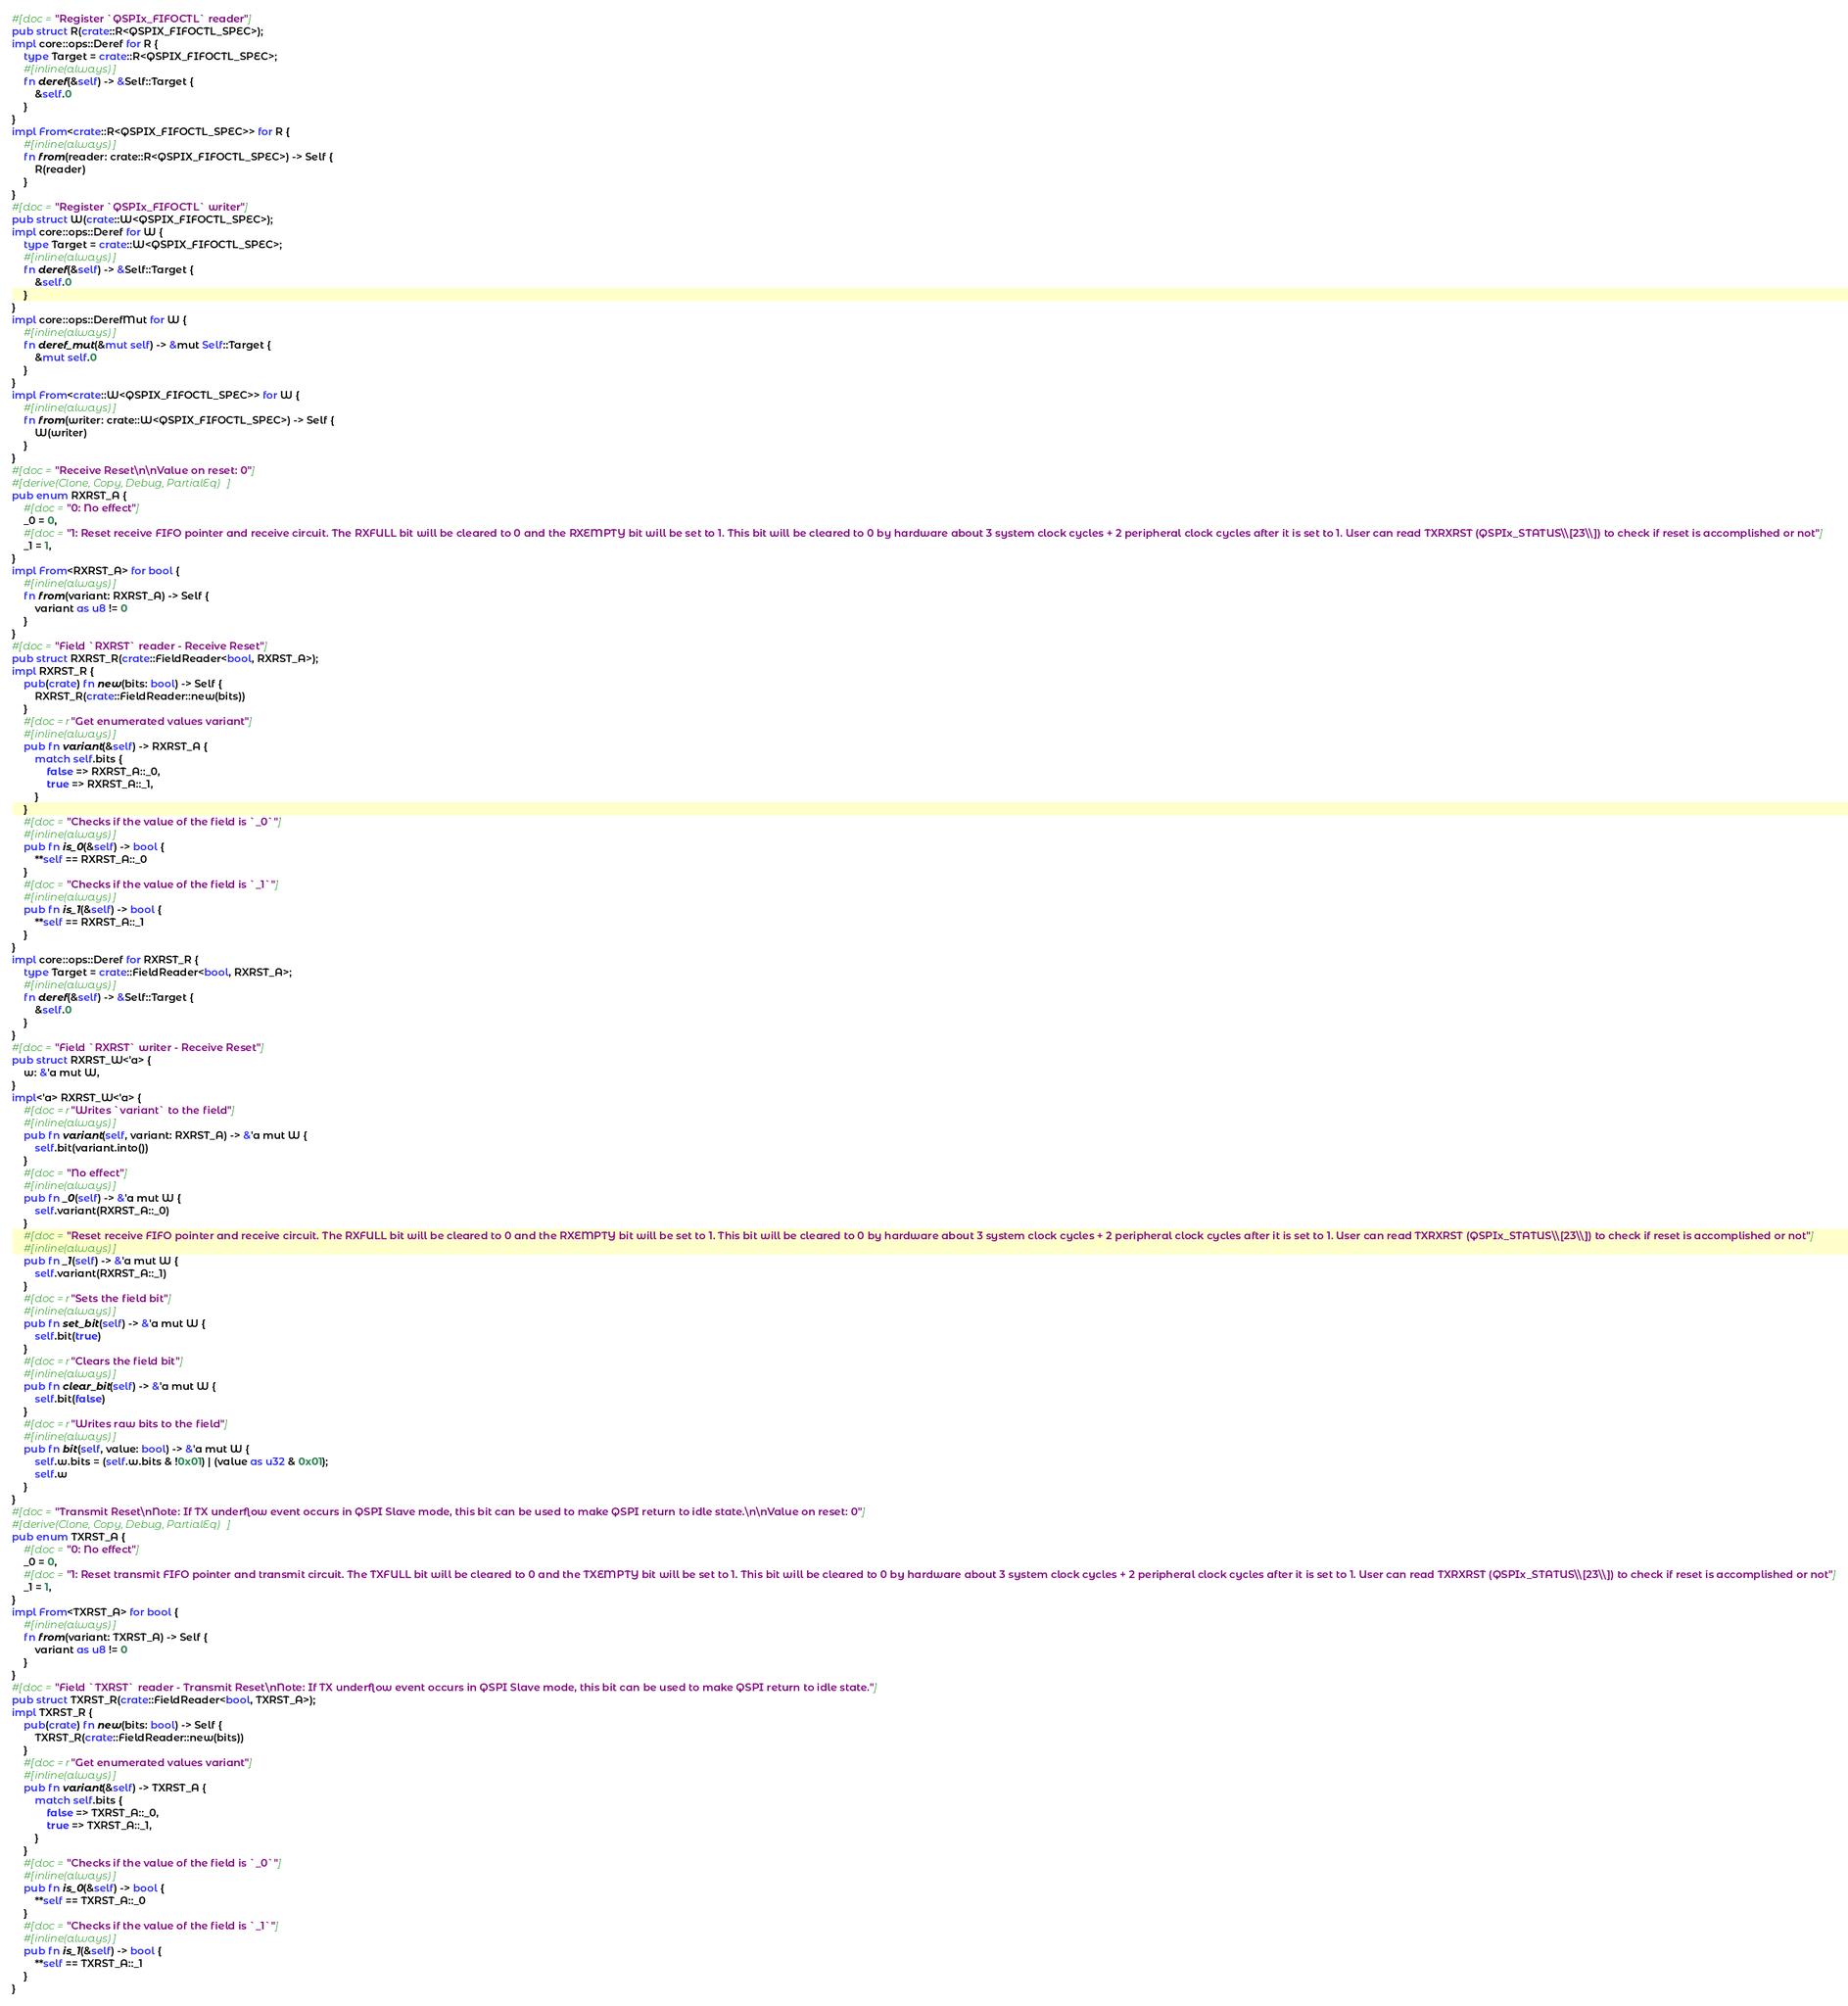<code> <loc_0><loc_0><loc_500><loc_500><_Rust_>#[doc = "Register `QSPIx_FIFOCTL` reader"]
pub struct R(crate::R<QSPIX_FIFOCTL_SPEC>);
impl core::ops::Deref for R {
    type Target = crate::R<QSPIX_FIFOCTL_SPEC>;
    #[inline(always)]
    fn deref(&self) -> &Self::Target {
        &self.0
    }
}
impl From<crate::R<QSPIX_FIFOCTL_SPEC>> for R {
    #[inline(always)]
    fn from(reader: crate::R<QSPIX_FIFOCTL_SPEC>) -> Self {
        R(reader)
    }
}
#[doc = "Register `QSPIx_FIFOCTL` writer"]
pub struct W(crate::W<QSPIX_FIFOCTL_SPEC>);
impl core::ops::Deref for W {
    type Target = crate::W<QSPIX_FIFOCTL_SPEC>;
    #[inline(always)]
    fn deref(&self) -> &Self::Target {
        &self.0
    }
}
impl core::ops::DerefMut for W {
    #[inline(always)]
    fn deref_mut(&mut self) -> &mut Self::Target {
        &mut self.0
    }
}
impl From<crate::W<QSPIX_FIFOCTL_SPEC>> for W {
    #[inline(always)]
    fn from(writer: crate::W<QSPIX_FIFOCTL_SPEC>) -> Self {
        W(writer)
    }
}
#[doc = "Receive Reset\n\nValue on reset: 0"]
#[derive(Clone, Copy, Debug, PartialEq)]
pub enum RXRST_A {
    #[doc = "0: No effect"]
    _0 = 0,
    #[doc = "1: Reset receive FIFO pointer and receive circuit. The RXFULL bit will be cleared to 0 and the RXEMPTY bit will be set to 1. This bit will be cleared to 0 by hardware about 3 system clock cycles + 2 peripheral clock cycles after it is set to 1. User can read TXRXRST (QSPIx_STATUS\\[23\\]) to check if reset is accomplished or not"]
    _1 = 1,
}
impl From<RXRST_A> for bool {
    #[inline(always)]
    fn from(variant: RXRST_A) -> Self {
        variant as u8 != 0
    }
}
#[doc = "Field `RXRST` reader - Receive Reset"]
pub struct RXRST_R(crate::FieldReader<bool, RXRST_A>);
impl RXRST_R {
    pub(crate) fn new(bits: bool) -> Self {
        RXRST_R(crate::FieldReader::new(bits))
    }
    #[doc = r"Get enumerated values variant"]
    #[inline(always)]
    pub fn variant(&self) -> RXRST_A {
        match self.bits {
            false => RXRST_A::_0,
            true => RXRST_A::_1,
        }
    }
    #[doc = "Checks if the value of the field is `_0`"]
    #[inline(always)]
    pub fn is_0(&self) -> bool {
        **self == RXRST_A::_0
    }
    #[doc = "Checks if the value of the field is `_1`"]
    #[inline(always)]
    pub fn is_1(&self) -> bool {
        **self == RXRST_A::_1
    }
}
impl core::ops::Deref for RXRST_R {
    type Target = crate::FieldReader<bool, RXRST_A>;
    #[inline(always)]
    fn deref(&self) -> &Self::Target {
        &self.0
    }
}
#[doc = "Field `RXRST` writer - Receive Reset"]
pub struct RXRST_W<'a> {
    w: &'a mut W,
}
impl<'a> RXRST_W<'a> {
    #[doc = r"Writes `variant` to the field"]
    #[inline(always)]
    pub fn variant(self, variant: RXRST_A) -> &'a mut W {
        self.bit(variant.into())
    }
    #[doc = "No effect"]
    #[inline(always)]
    pub fn _0(self) -> &'a mut W {
        self.variant(RXRST_A::_0)
    }
    #[doc = "Reset receive FIFO pointer and receive circuit. The RXFULL bit will be cleared to 0 and the RXEMPTY bit will be set to 1. This bit will be cleared to 0 by hardware about 3 system clock cycles + 2 peripheral clock cycles after it is set to 1. User can read TXRXRST (QSPIx_STATUS\\[23\\]) to check if reset is accomplished or not"]
    #[inline(always)]
    pub fn _1(self) -> &'a mut W {
        self.variant(RXRST_A::_1)
    }
    #[doc = r"Sets the field bit"]
    #[inline(always)]
    pub fn set_bit(self) -> &'a mut W {
        self.bit(true)
    }
    #[doc = r"Clears the field bit"]
    #[inline(always)]
    pub fn clear_bit(self) -> &'a mut W {
        self.bit(false)
    }
    #[doc = r"Writes raw bits to the field"]
    #[inline(always)]
    pub fn bit(self, value: bool) -> &'a mut W {
        self.w.bits = (self.w.bits & !0x01) | (value as u32 & 0x01);
        self.w
    }
}
#[doc = "Transmit Reset\nNote: If TX underflow event occurs in QSPI Slave mode, this bit can be used to make QSPI return to idle state.\n\nValue on reset: 0"]
#[derive(Clone, Copy, Debug, PartialEq)]
pub enum TXRST_A {
    #[doc = "0: No effect"]
    _0 = 0,
    #[doc = "1: Reset transmit FIFO pointer and transmit circuit. The TXFULL bit will be cleared to 0 and the TXEMPTY bit will be set to 1. This bit will be cleared to 0 by hardware about 3 system clock cycles + 2 peripheral clock cycles after it is set to 1. User can read TXRXRST (QSPIx_STATUS\\[23\\]) to check if reset is accomplished or not"]
    _1 = 1,
}
impl From<TXRST_A> for bool {
    #[inline(always)]
    fn from(variant: TXRST_A) -> Self {
        variant as u8 != 0
    }
}
#[doc = "Field `TXRST` reader - Transmit Reset\nNote: If TX underflow event occurs in QSPI Slave mode, this bit can be used to make QSPI return to idle state."]
pub struct TXRST_R(crate::FieldReader<bool, TXRST_A>);
impl TXRST_R {
    pub(crate) fn new(bits: bool) -> Self {
        TXRST_R(crate::FieldReader::new(bits))
    }
    #[doc = r"Get enumerated values variant"]
    #[inline(always)]
    pub fn variant(&self) -> TXRST_A {
        match self.bits {
            false => TXRST_A::_0,
            true => TXRST_A::_1,
        }
    }
    #[doc = "Checks if the value of the field is `_0`"]
    #[inline(always)]
    pub fn is_0(&self) -> bool {
        **self == TXRST_A::_0
    }
    #[doc = "Checks if the value of the field is `_1`"]
    #[inline(always)]
    pub fn is_1(&self) -> bool {
        **self == TXRST_A::_1
    }
}</code> 